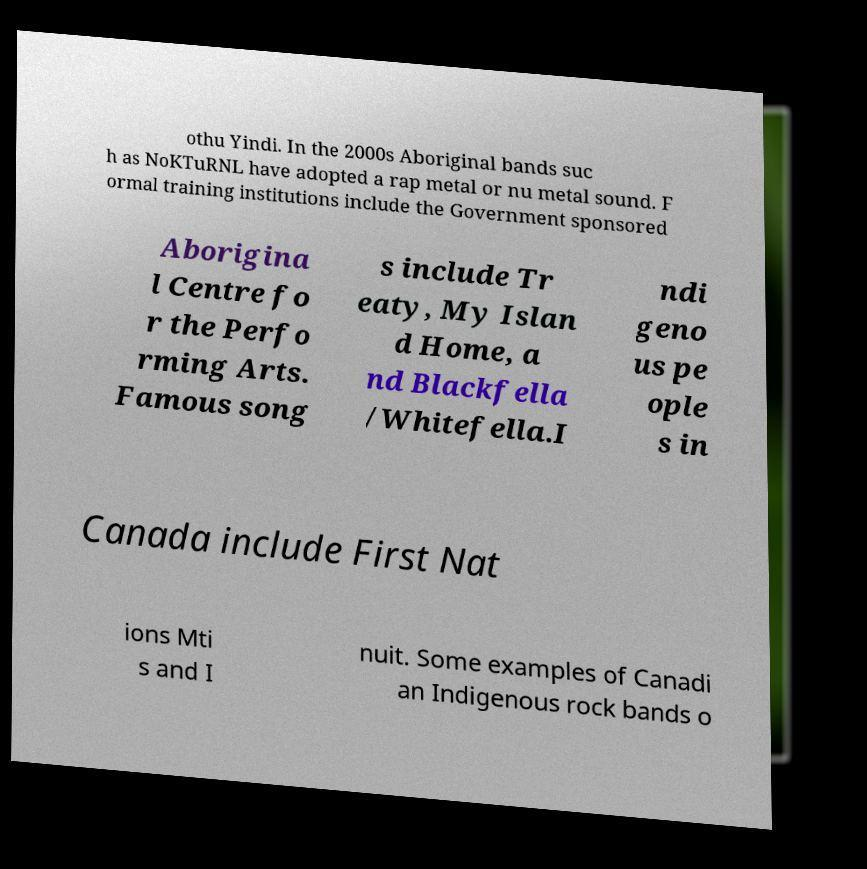Can you accurately transcribe the text from the provided image for me? othu Yindi. In the 2000s Aboriginal bands suc h as NoKTuRNL have adopted a rap metal or nu metal sound. F ormal training institutions include the Government sponsored Aborigina l Centre fo r the Perfo rming Arts. Famous song s include Tr eaty, My Islan d Home, a nd Blackfella /Whitefella.I ndi geno us pe ople s in Canada include First Nat ions Mti s and I nuit. Some examples of Canadi an Indigenous rock bands o 